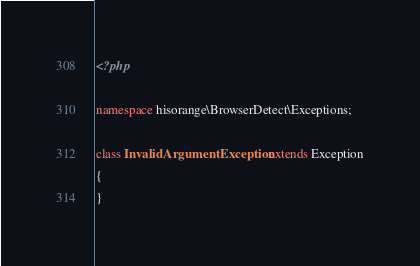Convert code to text. <code><loc_0><loc_0><loc_500><loc_500><_PHP_><?php

namespace hisorange\BrowserDetect\Exceptions;

class InvalidArgumentException extends Exception
{
}
</code> 